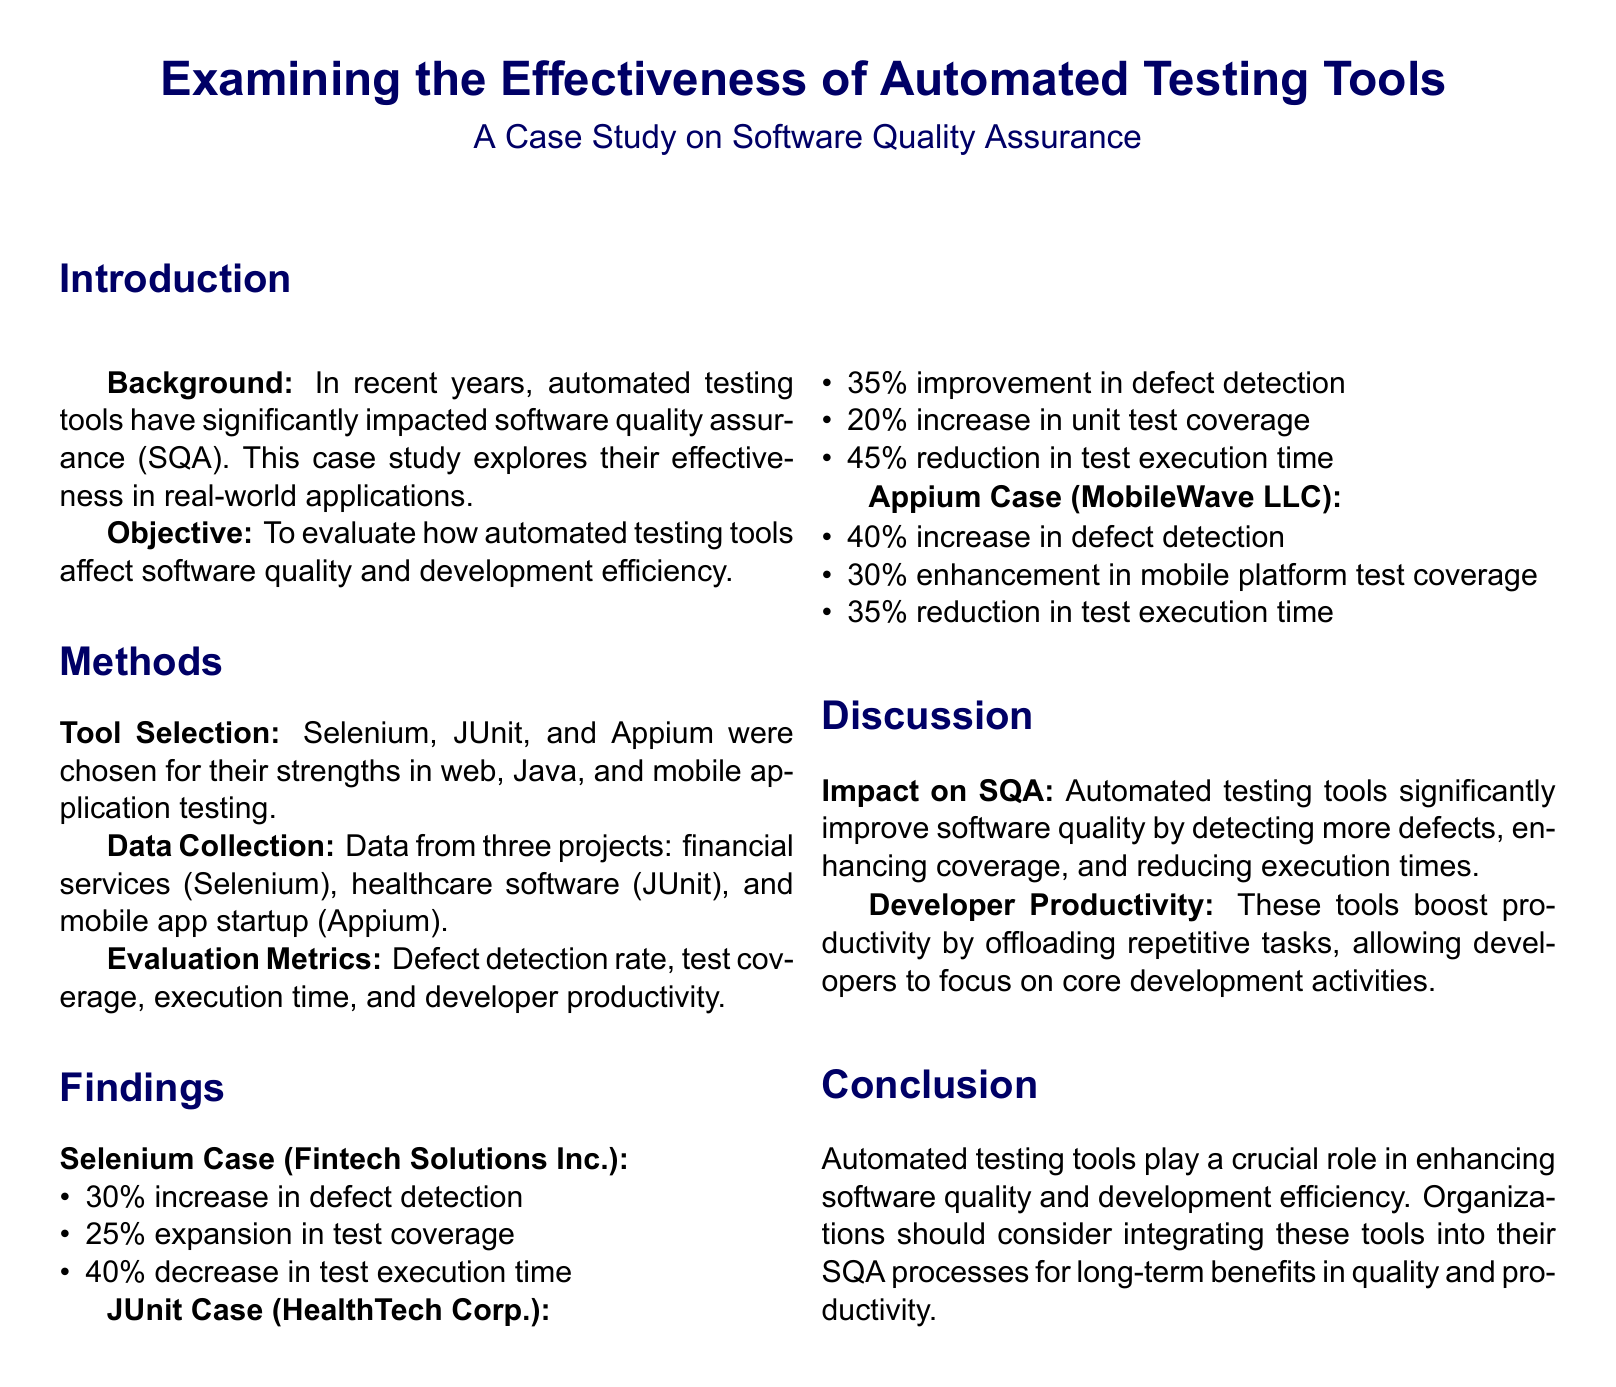What are the selected tools for automated testing? The document lists the selected tools for automated testing as Selenium, JUnit, and Appium.
Answer: Selenium, JUnit, Appium What was the defect detection increase for Selenium? The document states that the Selenium case saw a 30% increase in defect detection.
Answer: 30% What was the test execution time reduction for JUnit? According to the document, the JUnit case experienced a 45% reduction in test execution time.
Answer: 45% How much did mobile platform test coverage enhance with Appium? The findings for the Appium case indicate a 30% enhancement in mobile platform test coverage.
Answer: 30% What was the main objective of the case study? The objective of the case study was to evaluate how automated testing tools affect software quality and development efficiency.
Answer: Evaluate effect on software quality and efficiency What type of projects were analyzed in the case study? The case study analyzed projects from financial services, healthcare software, and a mobile app startup.
Answer: Financial services, healthcare software, mobile app startup What impact do automated testing tools have on developer productivity? The document discusses that these tools boost productivity by offloading repetitive tasks.
Answer: Boost productivity What is a crucial role of automated testing tools mentioned in the conclusion? The conclusion highlights that automated testing tools enhance software quality and development efficiency.
Answer: Enhancing software quality and efficiency How did Selenium affect test coverage? The document states that Selenium resulted in a 25% expansion in test coverage.
Answer: 25% expansion 